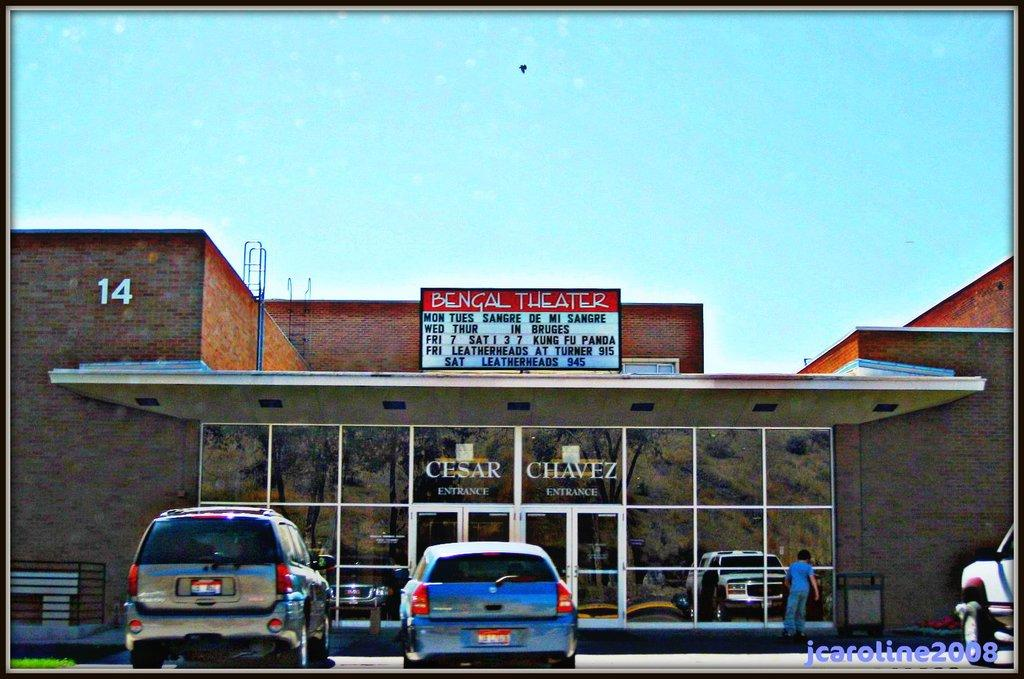What type of establishment is depicted in the image? The image appears to depict a movie theater. What can be seen in front of the theater? There are vehicles parked in front of the theater. Is there anyone visible in the image? Yes, there is a person on the right side of the image. What type of glass can be seen on the island in the image? There is no island or glass present in the image; it depicts a movie theater with vehicles parked in front and a person on the right side. Is there a fire visible in the image? No, there is no fire present in the image. 